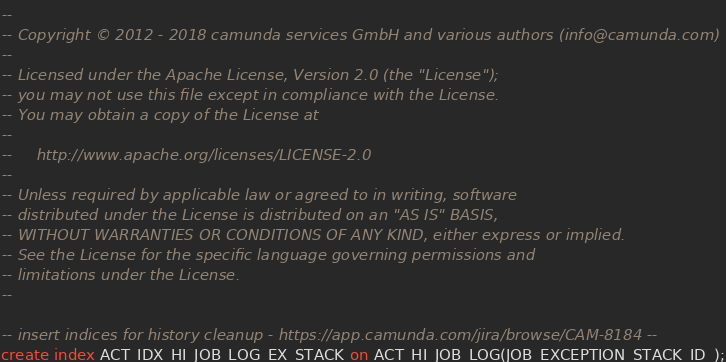Convert code to text. <code><loc_0><loc_0><loc_500><loc_500><_SQL_>--
-- Copyright © 2012 - 2018 camunda services GmbH and various authors (info@camunda.com)
--
-- Licensed under the Apache License, Version 2.0 (the "License");
-- you may not use this file except in compliance with the License.
-- You may obtain a copy of the License at
--
--     http://www.apache.org/licenses/LICENSE-2.0
--
-- Unless required by applicable law or agreed to in writing, software
-- distributed under the License is distributed on an "AS IS" BASIS,
-- WITHOUT WARRANTIES OR CONDITIONS OF ANY KIND, either express or implied.
-- See the License for the specific language governing permissions and
-- limitations under the License.
--

-- insert indices for history cleanup - https://app.camunda.com/jira/browse/CAM-8184 --
create index ACT_IDX_HI_JOB_LOG_EX_STACK on ACT_HI_JOB_LOG(JOB_EXCEPTION_STACK_ID_);</code> 